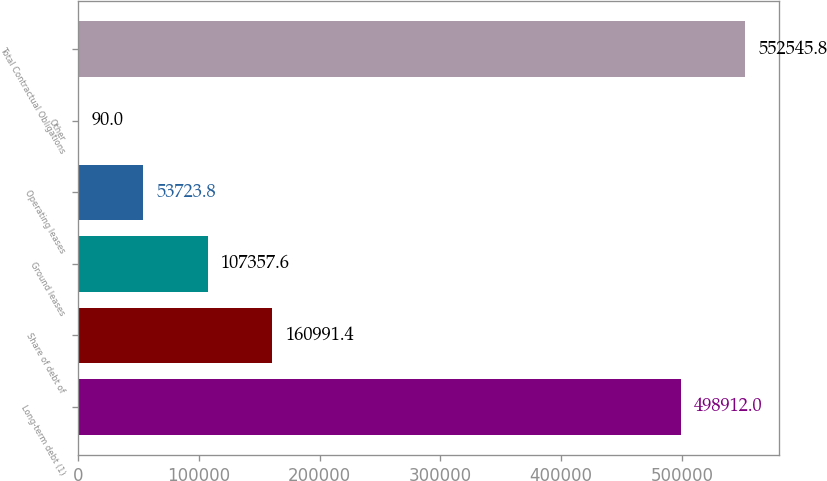<chart> <loc_0><loc_0><loc_500><loc_500><bar_chart><fcel>Long-term debt (1)<fcel>Share of debt of<fcel>Ground leases<fcel>Operating leases<fcel>Other<fcel>Total Contractual Obligations<nl><fcel>498912<fcel>160991<fcel>107358<fcel>53723.8<fcel>90<fcel>552546<nl></chart> 